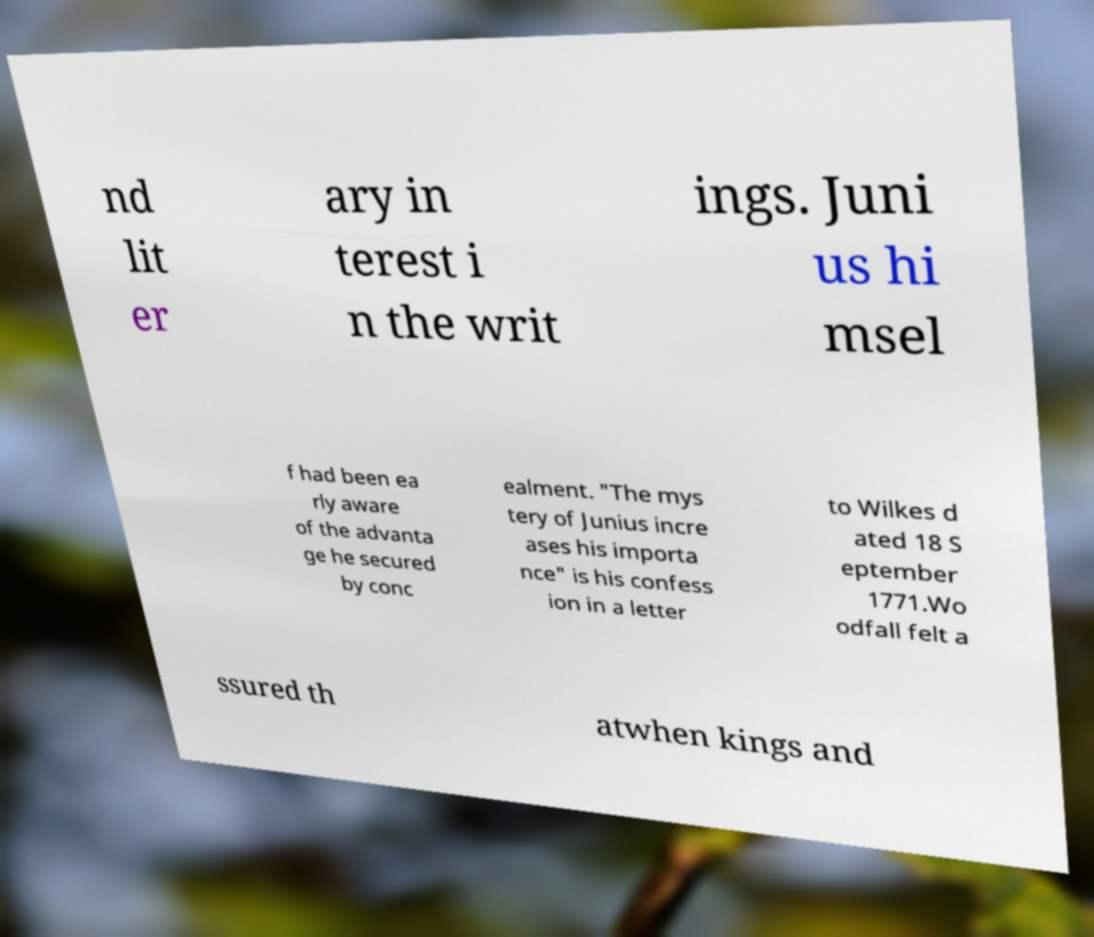Can you read and provide the text displayed in the image?This photo seems to have some interesting text. Can you extract and type it out for me? nd lit er ary in terest i n the writ ings. Juni us hi msel f had been ea rly aware of the advanta ge he secured by conc ealment. "The mys tery of Junius incre ases his importa nce" is his confess ion in a letter to Wilkes d ated 18 S eptember 1771.Wo odfall felt a ssured th atwhen kings and 